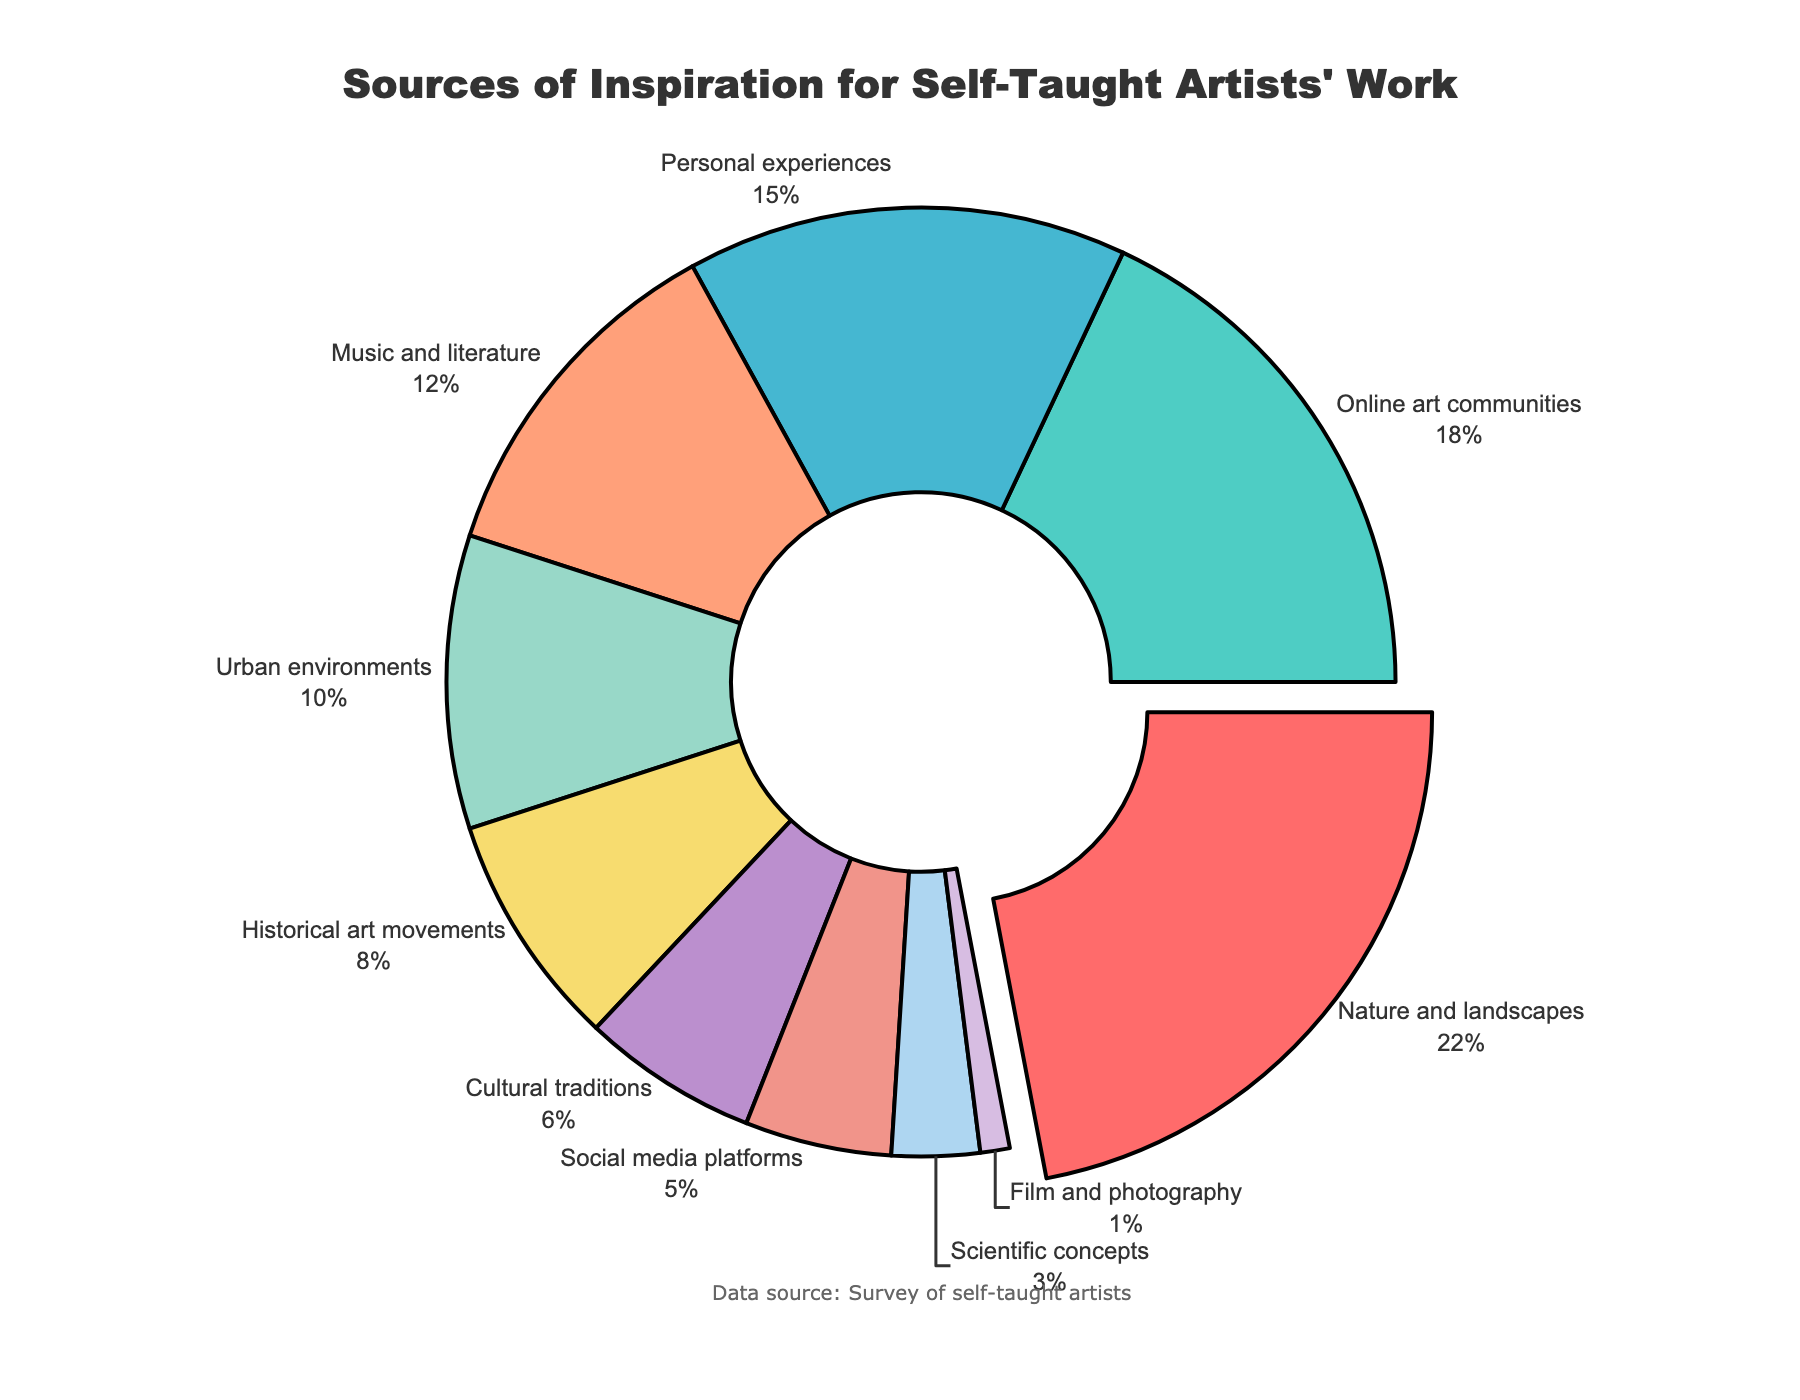Which source of inspiration has the largest percentage share? Refer to the section of the pie chart that is largest in size and is pulled slightly out from the center. That section is "Nature and landscapes" with 22%.
Answer: Nature and landscapes What is the combined percentage of inspiration from Music and literature and Social media platforms? Look at the percentage shares for Music and literature (12%) and Social media platforms (5%). Add them together: 12 + 5 = 17.
Answer: 17% Which source of inspiration has the least influence on self-taught artists' work? Identify the section of the pie chart that is the smallest. The smallest section is "Film and photography" with 1%.
Answer: Film and photography How many sources of inspiration have a percentage share above 10%? Check each section of the pie chart. "Nature and landscapes" (22%), "Online art communities" (18%), "Personal experiences" (15%), and "Music and literature" (12%) all have percentages above 10%. The total is 4.
Answer: 4 Is the percentage of inspiration from Historical art movements greater than that from Cultural traditions? Compare the percentages in the chart. Historical art movements have 8% and Cultural traditions have 6%. Since 8% is greater than 6%, the answer is yes.
Answer: Yes What is the difference in percentage points between the highest and lowest sources of inspiration? Identify the highest percentage ("Nature and landscapes" with 22%) and the lowest ("Film and photography" with 1%). Subtract the lowest from the highest: 22 - 1 = 21.
Answer: 21 Which sources of inspiration each contribute less than 10% to the artists' work? Identify all sections in the pie chart with percentages below 10%. They are "Historical art movements" (8%), "Cultural traditions" (6%), "Social media platforms" (5%), "Scientific concepts" (3%), and "Film and photography" (1%).
Answer: Historical art movements, Cultural traditions, Social media platforms, Scientific concepts, Film and photography Between Online art communities and Urban environments, which has a larger percentage and by how much? Compare their percentages. Online art communities have 18% and Urban environments have 10%. Calculate the difference: 18 - 10 = 8. So, Online art communities is larger by 8%.
Answer: Online art communities by 8% If we sum the percentages of Cultural traditions, Social media platforms, and Scientific concepts, what is the total? Add their percentages together: Cultural traditions (6%) + Social media platforms (5%) + Scientific concepts (3%) = 6 + 5 + 3 = 14.
Answer: 14% Which two sources of inspiration together make up more than one-third of the total share? One-third of 100% is approximately 33.33%. Check pairs of sources: "Nature and landscapes" (22%) + "Online art communities" (18%) = 40%, which is more than one-third. This is the correct pair.
Answer: Nature and landscapes and Online art communities 